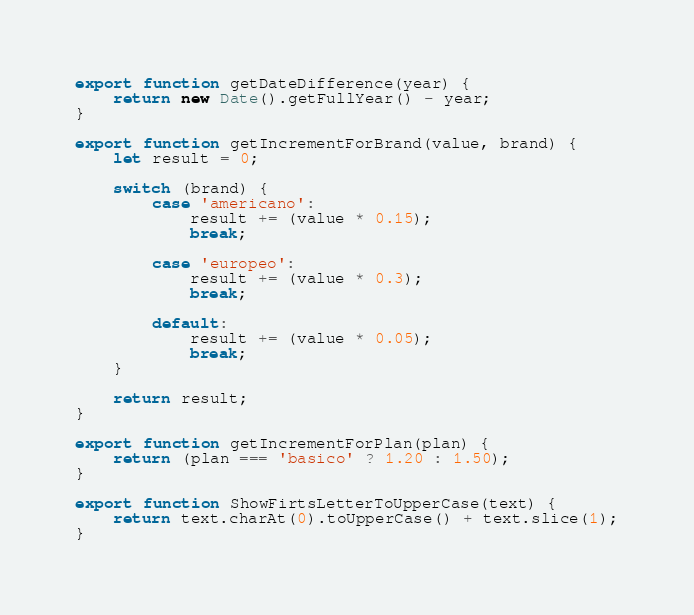<code> <loc_0><loc_0><loc_500><loc_500><_JavaScript_>export function getDateDifference(year) {
    return new Date().getFullYear() - year;
}

export function getIncrementForBrand(value, brand) {
    let result = 0;

    switch (brand) {
        case 'americano':
            result += (value * 0.15);
            break;

        case 'europeo':
            result += (value * 0.3);
            break;
    
        default:
            result += (value * 0.05);
            break;
    }

    return result;
}

export function getIncrementForPlan(plan) {
    return (plan === 'basico' ? 1.20 : 1.50);
}

export function ShowFirtsLetterToUpperCase(text) {
    return text.charAt(0).toUpperCase() + text.slice(1);
}</code> 